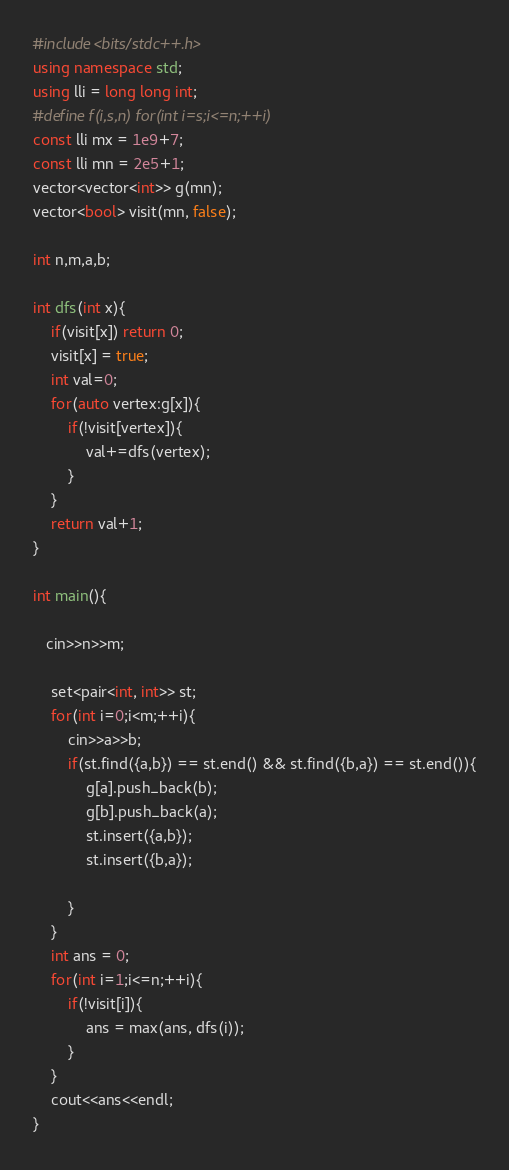Convert code to text. <code><loc_0><loc_0><loc_500><loc_500><_C++_>#include<bits/stdc++.h>
using namespace std;
using lli = long long int;
#define f(i,s,n) for(int i=s;i<=n;++i)
const lli mx = 1e9+7;
const lli mn = 2e5+1;
vector<vector<int>> g(mn);
vector<bool> visit(mn, false);

int n,m,a,b;

int dfs(int x){
    if(visit[x]) return 0;
    visit[x] = true;
    int val=0;
    for(auto vertex:g[x]){
        if(!visit[vertex]){
            val+=dfs(vertex);
        }
    }
    return val+1;
}

int main(){
   
   cin>>n>>m;
    
    set<pair<int, int>> st;
    for(int i=0;i<m;++i){
        cin>>a>>b;
        if(st.find({a,b}) == st.end() && st.find({b,a}) == st.end()){
            g[a].push_back(b);
            g[b].push_back(a);
            st.insert({a,b});
            st.insert({b,a});
           
        }
    }
    int ans = 0;
    for(int i=1;i<=n;++i){
        if(!visit[i]){
            ans = max(ans, dfs(i));
        }
    }
    cout<<ans<<endl;
}</code> 